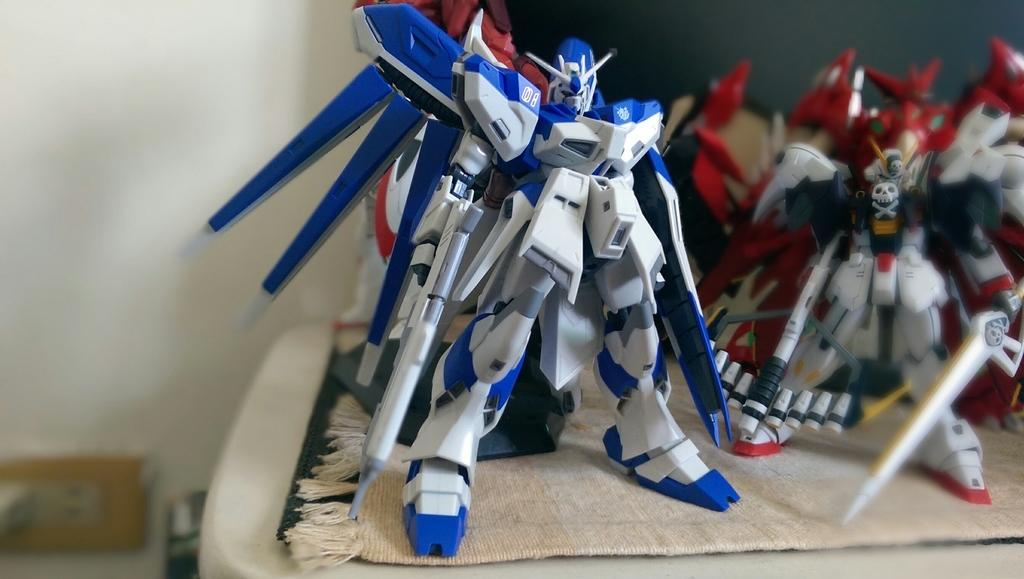What objects are present on the cloth in the image? There are toys on a cloth in the image. Can you describe the location of the socket in the image? There is a socket on the wall in the background of the image. What type of system is visible in the image? There is no system visible in the image; it only features toys on a cloth and a socket on the wall. What is the condition of the person's knee in the image? There is no person or knee present in the image. 